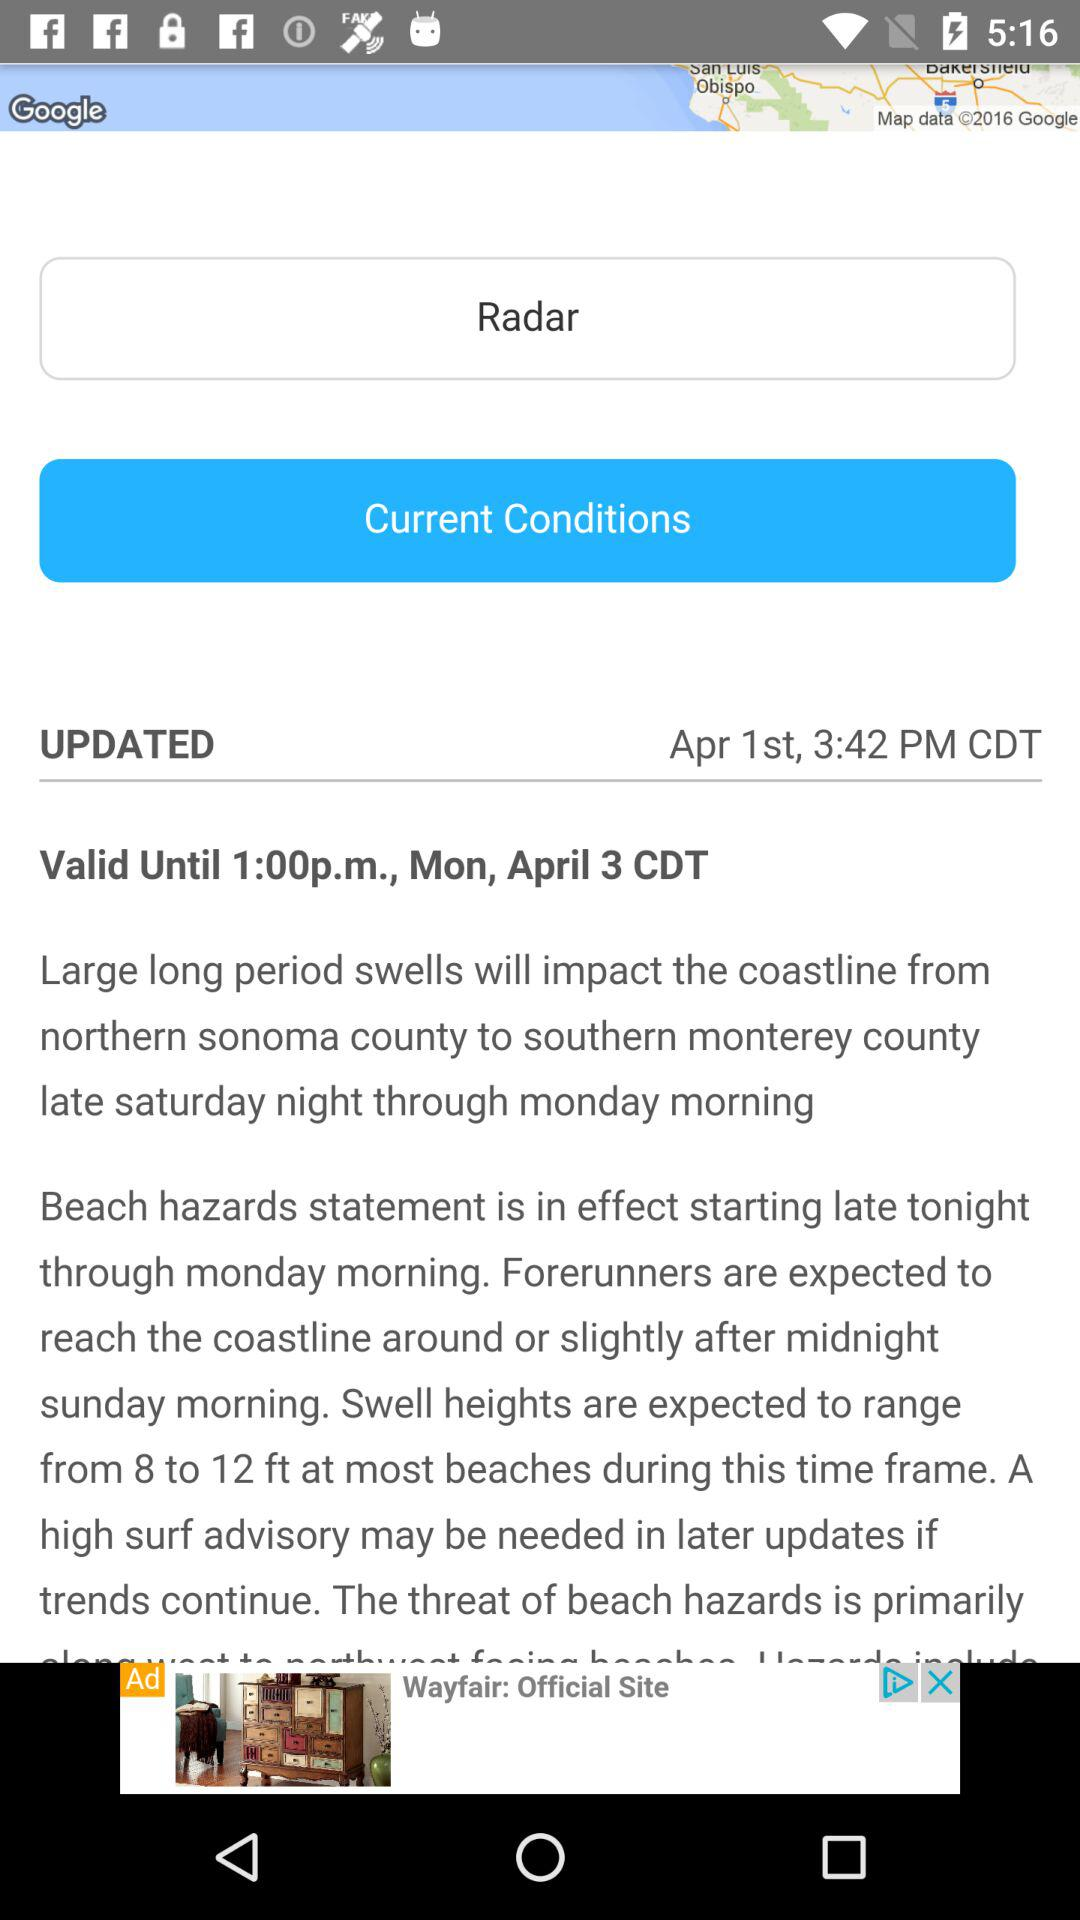What is the updated date? The date is April 1. 